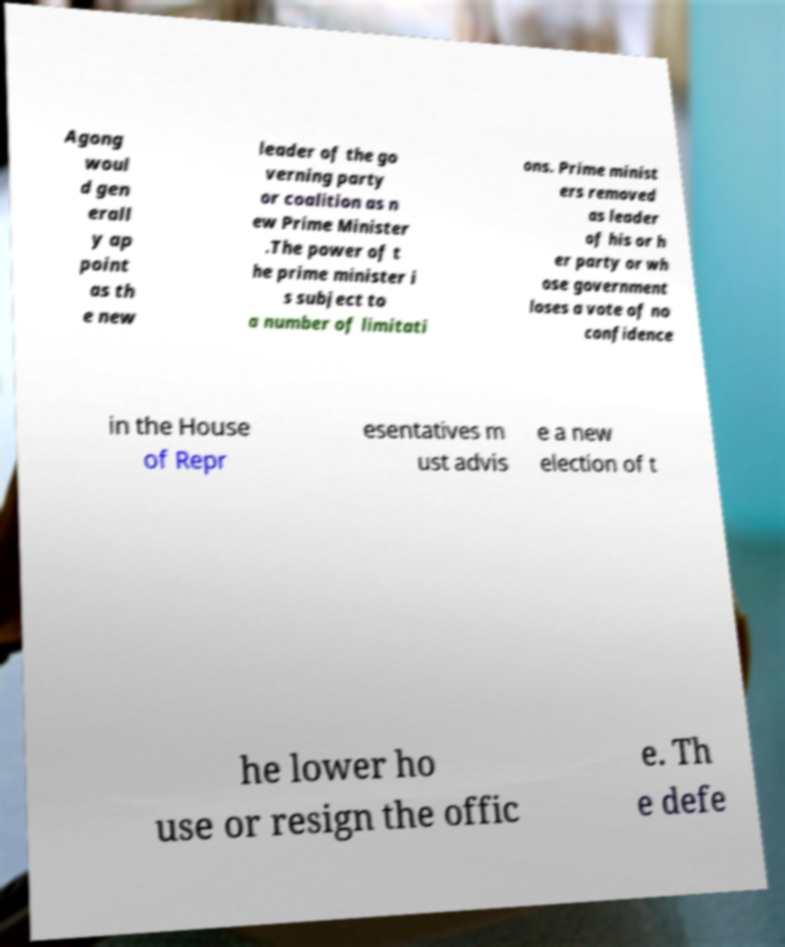Could you extract and type out the text from this image? Agong woul d gen erall y ap point as th e new leader of the go verning party or coalition as n ew Prime Minister .The power of t he prime minister i s subject to a number of limitati ons. Prime minist ers removed as leader of his or h er party or wh ose government loses a vote of no confidence in the House of Repr esentatives m ust advis e a new election of t he lower ho use or resign the offic e. Th e defe 